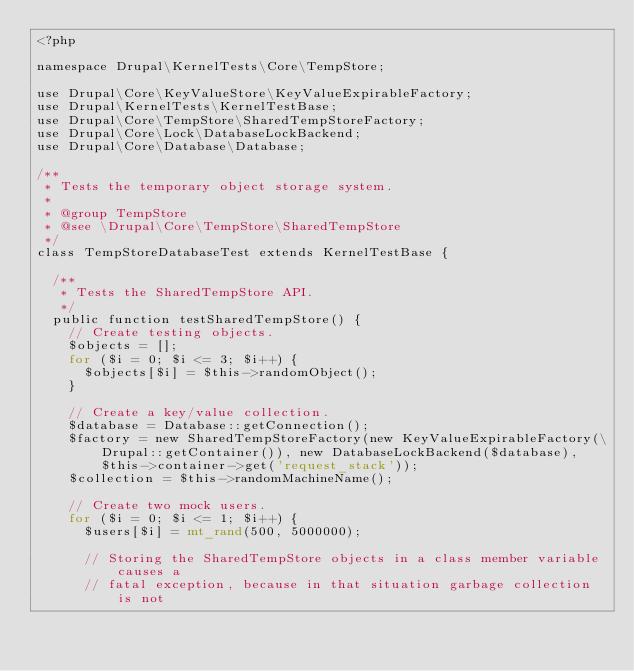<code> <loc_0><loc_0><loc_500><loc_500><_PHP_><?php

namespace Drupal\KernelTests\Core\TempStore;

use Drupal\Core\KeyValueStore\KeyValueExpirableFactory;
use Drupal\KernelTests\KernelTestBase;
use Drupal\Core\TempStore\SharedTempStoreFactory;
use Drupal\Core\Lock\DatabaseLockBackend;
use Drupal\Core\Database\Database;

/**
 * Tests the temporary object storage system.
 *
 * @group TempStore
 * @see \Drupal\Core\TempStore\SharedTempStore
 */
class TempStoreDatabaseTest extends KernelTestBase {

  /**
   * Tests the SharedTempStore API.
   */
  public function testSharedTempStore() {
    // Create testing objects.
    $objects = [];
    for ($i = 0; $i <= 3; $i++) {
      $objects[$i] = $this->randomObject();
    }

    // Create a key/value collection.
    $database = Database::getConnection();
    $factory = new SharedTempStoreFactory(new KeyValueExpirableFactory(\Drupal::getContainer()), new DatabaseLockBackend($database), $this->container->get('request_stack'));
    $collection = $this->randomMachineName();

    // Create two mock users.
    for ($i = 0; $i <= 1; $i++) {
      $users[$i] = mt_rand(500, 5000000);

      // Storing the SharedTempStore objects in a class member variable causes a
      // fatal exception, because in that situation garbage collection is not</code> 